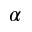<formula> <loc_0><loc_0><loc_500><loc_500>\alpha</formula> 